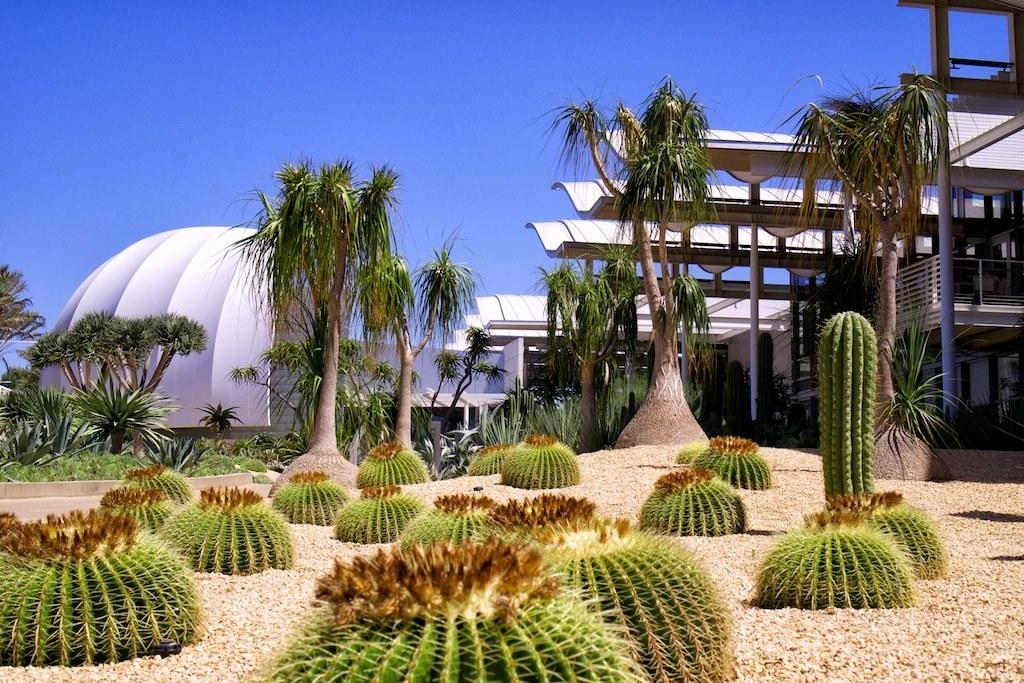What type of environment is depicted in the image? The image is an outside view. What type of vegetation can be seen on the ground? There are cactus plants on the ground. What can be seen in the background of the image? There are trees and buildings in the background. What is visible at the top of the image? The sky is visible at the top of the image. What is the health condition of the arch in the image? There is no arch present in the image, so it is not possible to determine its health condition. 